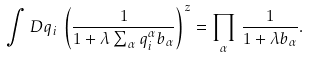Convert formula to latex. <formula><loc_0><loc_0><loc_500><loc_500>\int D q _ { i } \, \left ( \frac { 1 } { 1 + \lambda \sum _ { \alpha } q ^ { \alpha } _ { i } b _ { \alpha } } \right ) ^ { z } = \prod _ { \alpha } \, \frac { 1 } { 1 + \lambda b _ { \alpha } } .</formula> 